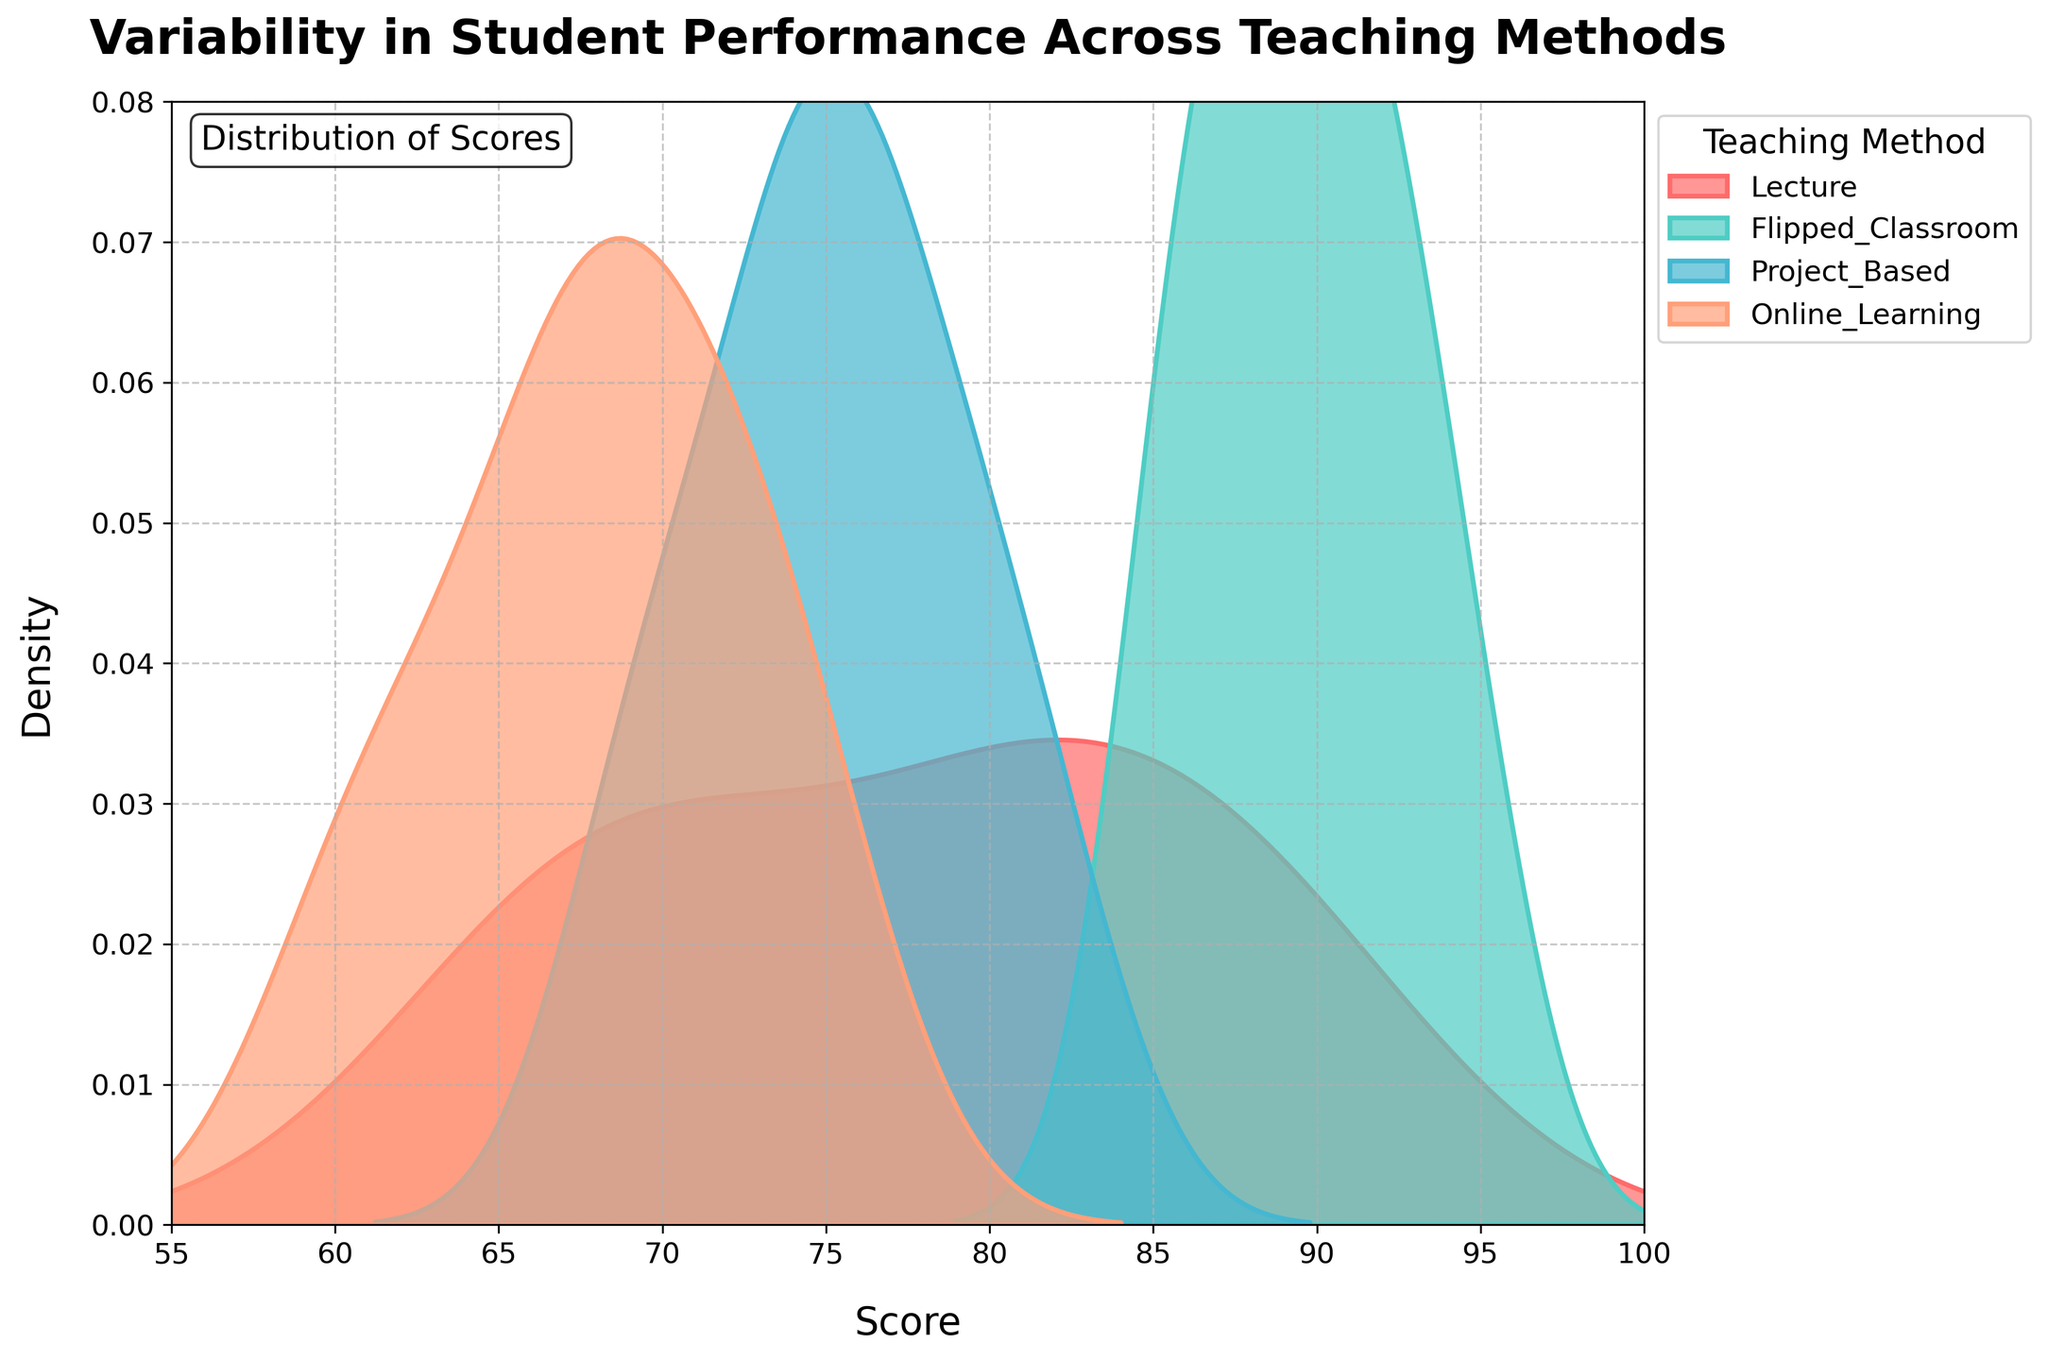What is the title of this plot? The title of the plot is typically positioned at the top center of the figure. It clearly describes the content of the plot.
Answer: Variability in Student Performance Across Teaching Methods Which teaching method shows the highest peak in the density plot? The highest peak in the density plot indicates the teaching method with the highest density of scores at a particular value.
Answer: Flipped Classroom What is the x-axis label in this plot? The x-axis label is located along the horizontal axis of the plot and indicates what data is being represented on that axis.
Answer: Score Which teaching method has a peak around a score of 70? By observing the density plot, one can identify the teaching method with a peak around a score of 70.
Answer: Online Learning Between "Lecture" and "Project Based", which teaching method shows a greater spread in scores? To determine this, we compare the width of the density curves for each method. A wider spread indicates greater variability in scores.
Answer: Lecture What range of scores does the x-axis cover? The x-axis range in a density plot is marked by the minimum and maximum values displayed on the axis.
Answer: 55 to 100 Which teaching method has the smallest peak density value? By looking at the y-axis and the corresponding peak value for each method, we can identify which one has the smallest peak density.
Answer: Project Based Is there any teaching method whose distribution peaks above a score of 90? By observing each density plot, we identify if any of them have a peak above the specified score.
Answer: Yes, Flipped Classroom How does the performance spread of "Flipped Classroom" compare to "Online Learning"? To compare, we look at the width of the density curves for both methods. A wider curve indicates a greater spread.
Answer: Flipped Classroom has a narrower spread than Online Learning What is the y-axis label in this plot? The y-axis label is found along the vertical axis of the plot and indicates what data is being represented on that axis.
Answer: Density 